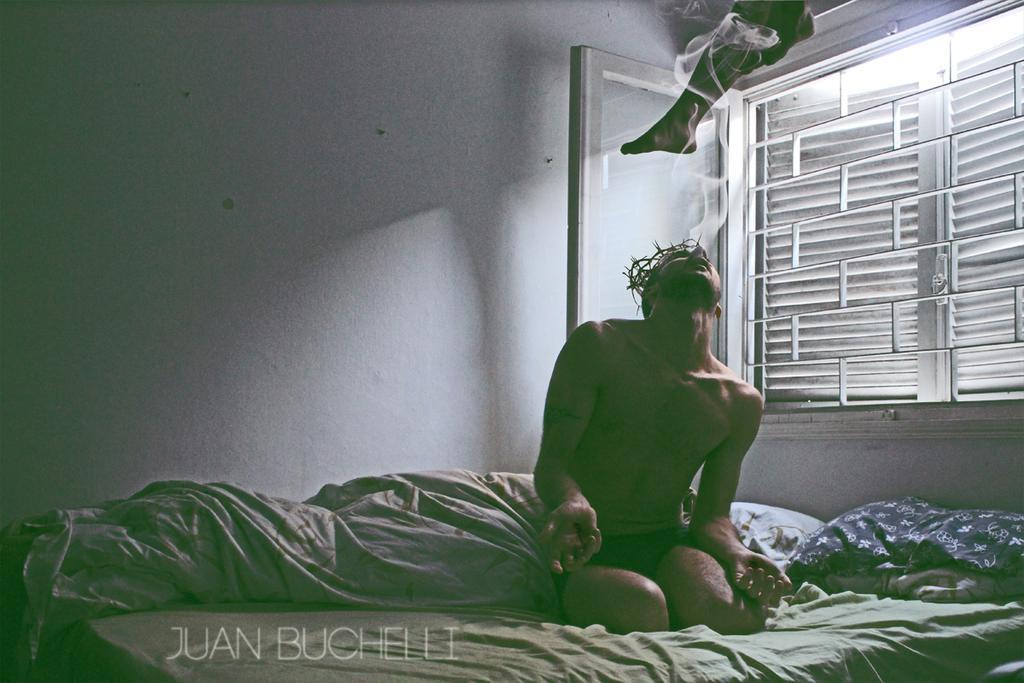Could you give a brief overview of what you see in this image? In this image in the center there is one bed, on the bed there are some blankets pillows and one person is sitting and smoking. And in the background there is a wall and a window and on the top there is another person. 